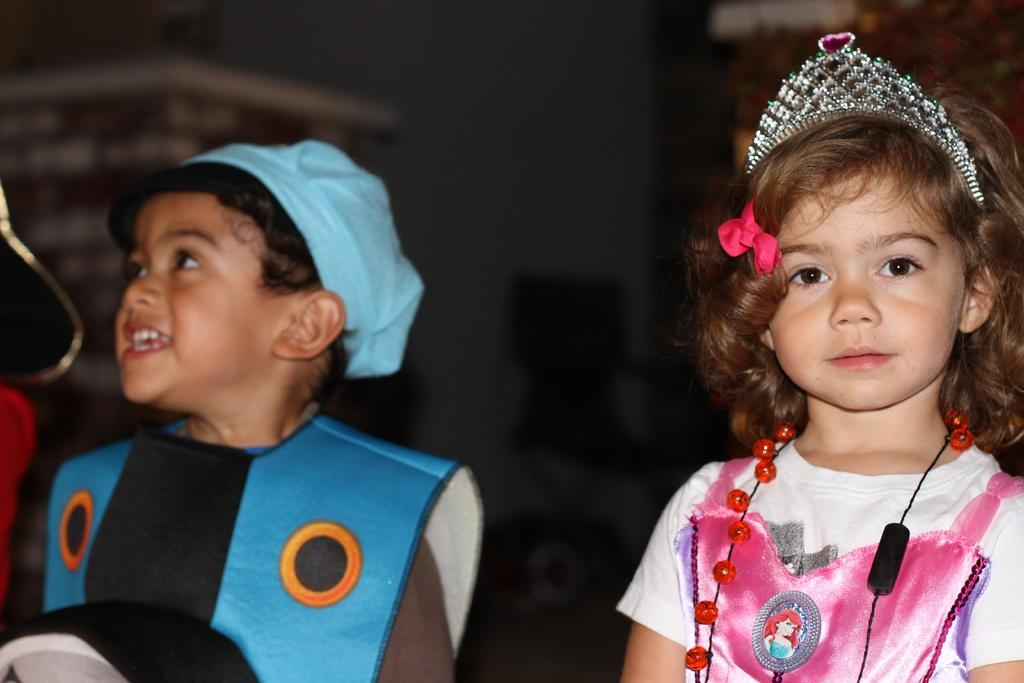What can be seen in the image? There are kids in the image. Can you describe the background of the image? The background is blurred, but there are objects visible in it. What type of jelly can be seen on the button in the image? There is no jelly or button present in the image. Is there a fire visible in the image? No, there is no fire visible in the image. 